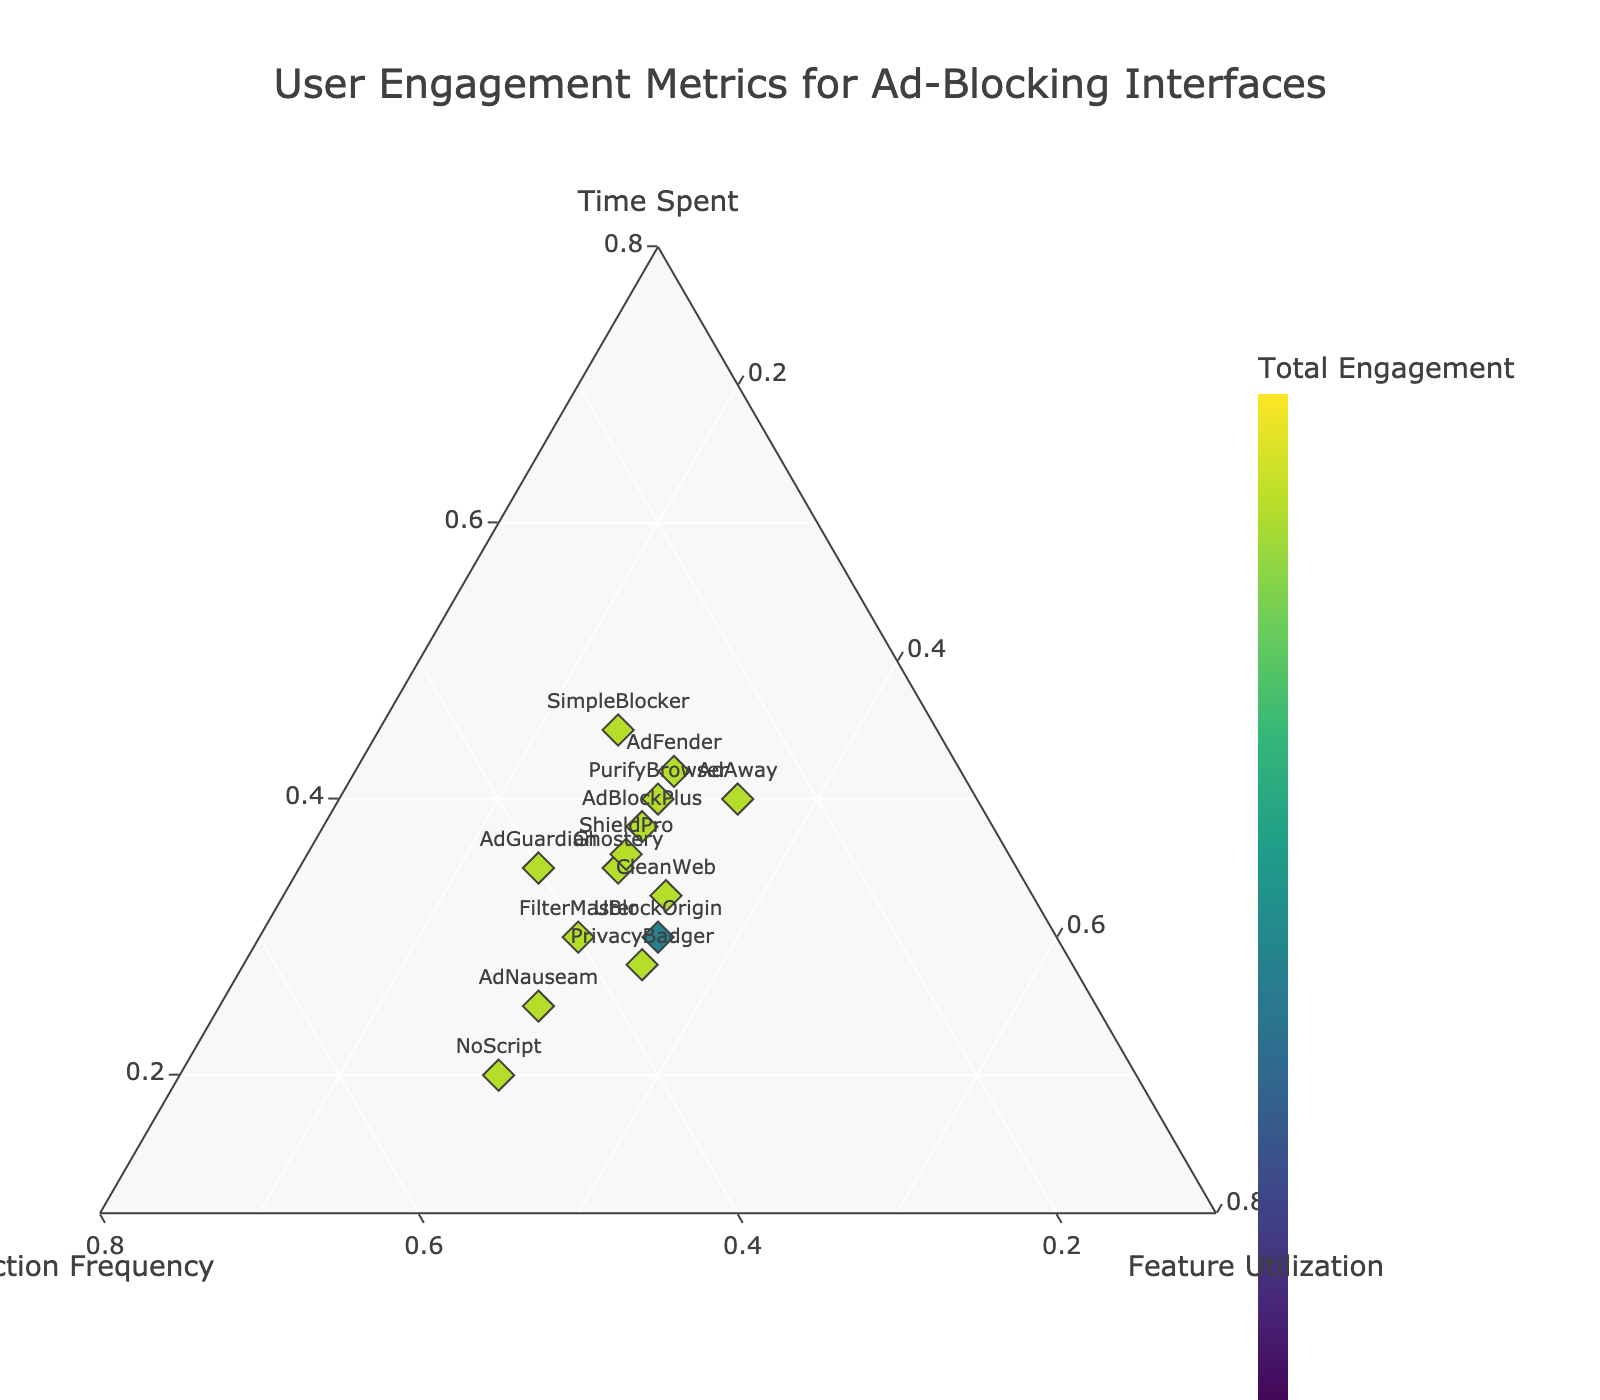What is the title of the plot? The title of the plot is positioned at the top center and reads "User Engagement Metrics for Ad-Blocking Interfaces".
Answer: User Engagement Metrics for Ad-Blocking Interfaces How many ad-blocking interfaces are represented in the plot? Counting the distinct labels or markers representing interfaces, there are 14 ad-blocking interfaces displayed in the plot.
Answer: 14 What is the hue color in the color scale representing? The hue color in the color scale represents the "Total Engagement," which is the sum of time spent, interaction frequency, and feature utilization for each interface.
Answer: Total Engagement Which interface has the highest interaction frequency? "NoScript" has the highest interaction frequency, as indicated by its position closer to the interaction frequency vertex in the ternary plot.
Answer: NoScript Which interface has the most balanced engagement among the three metrics? "CleanWeb" has the most balanced engagement because its point is equally distanced from all three vertices, showing similar values for time spent (0.33), interaction frequency (0.33), and feature utilization (0.34).
Answer: CleanWeb Comparing "SimpleBlocker" and "AdNauseam," which one has higher feature utilization? By looking at their positions on the ternary plot relative to the feature utilization axis, "SimpleBlocker" has a lower feature utilization (0.25) than "AdNauseam" (0.30).
Answer: AdNauseam Which interface has the highest total engagement? From the color intensity on the plot, "SimpleBlocker" shows the highest total engagement score.
Answer: SimpleBlocker How does "Ghostery" compare to "UBlockOrigin" in terms of time spent? "Ghostery" (0.35) has slightly higher time spent compared to "UBlockOrigin" (0.30), as deduced from their positions closer to the time spent vertex.
Answer: Ghostery What can you infer about "PurifyBrowser" in terms of its engagement metrics mix? "PurifyBrowser" shows a moderate mix across all three metrics, with a slight emphasis on time spent (0.40) but with relatively balanced interaction frequency (0.30) and feature utilization (0.30).
Answer: Moderate balance with emphasis on time spent Which interface has the lowest time spent? "NoScript" has the lowest time spent (0.20), as it is positioned closest to the interaction frequency and further from the time spent vertex.
Answer: NoScript 